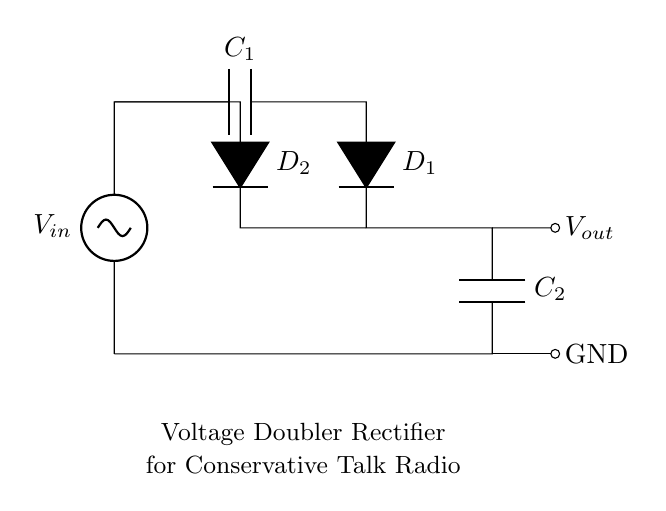What is the input voltage symbol in this circuit? The input voltage symbol is indicated as V in, which is usually represented as a voltage source. It shows where the initial voltage is applied to the circuit.
Answer: V in How many diodes are in the circuit? There are two diodes, represented as D1 and D2, which are used for rectification in the circuit. Diodes allow current to flow only in one direction.
Answer: 2 What type of circuit configuration is shown? The circuit configuration is a voltage doubler, which means it is designed to increase the voltage output relative to the input voltage. The arrangement of capacitors and diodes defines this function.
Answer: Voltage doubler What are the capacitor labels in this circuit? The capacitors are labeled C1 and C2, which signifies their individual roles within the circuit as they charge and discharge to create the doubled voltage effect.
Answer: C1, C2 What is the output voltage node in the circuit? The output voltage node is indicated at the point labeled V out, which is the location where the doubled voltage can be accessed from the circuit.
Answer: V out Explain how the voltage doubling effect is achieved. The voltage doubling effect occurs due to the arrangement of capacitors and diodes. Initially, C1 charges up to the input voltage, and when D1 conducts, C2 is charged by the sum of V in and the voltage across C1, effectively doubling the output voltage when discharged. This is a fundamental property of the circuit's configuration.
Answer: Through capacitor charging 